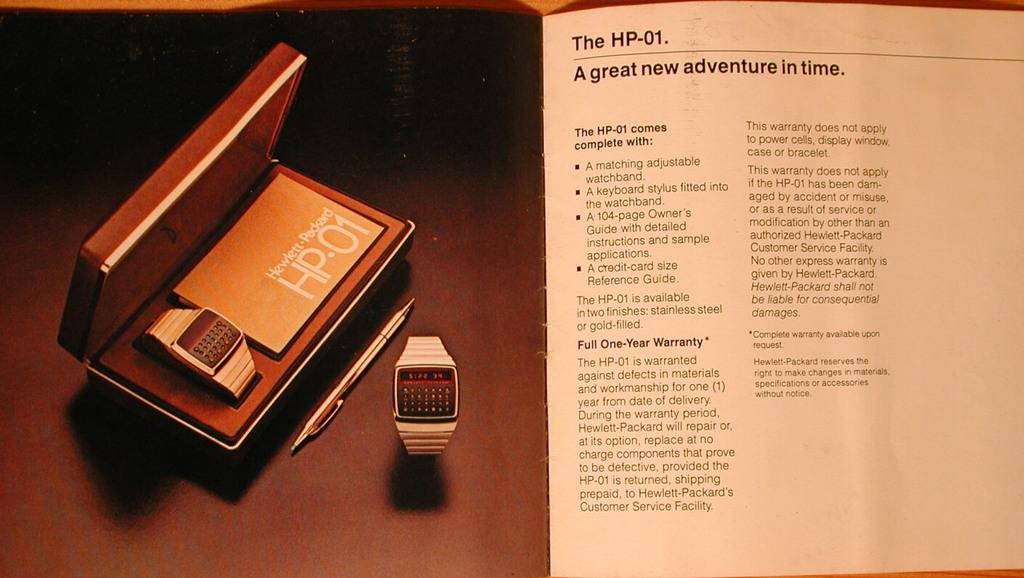<image>
Render a clear and concise summary of the photo. A brochure for the HP-01 watch is titled "A great new adventure in time". 